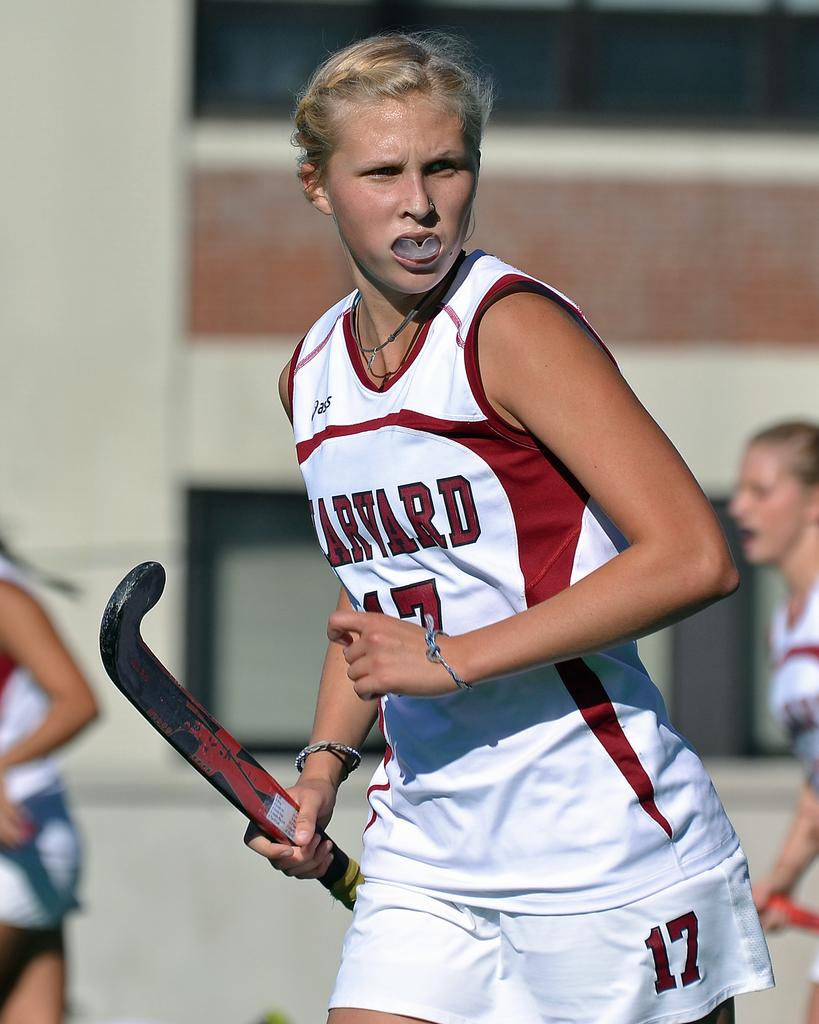<image>
Provide a brief description of the given image. number 17 for harvard looking away while holding stick and sticking out her mouthpiece 